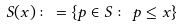<formula> <loc_0><loc_0><loc_500><loc_500>S ( x ) \colon = \{ p \in S \colon \, p \leq x \}</formula> 